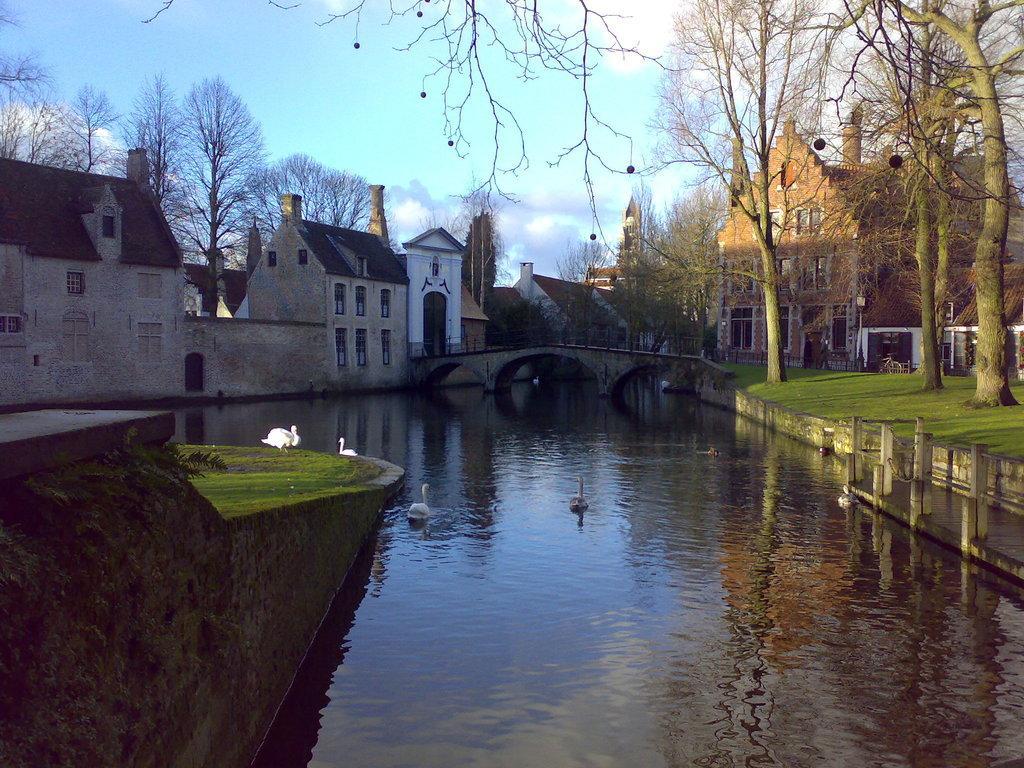How would you summarize this image in a sentence or two? At the bottom of the image there is water with swans. On the left side of the image there is a wall. And in the background there are buildings with walls, windows and roofs. And also there are many trees. At the top of the image there is a sky. 